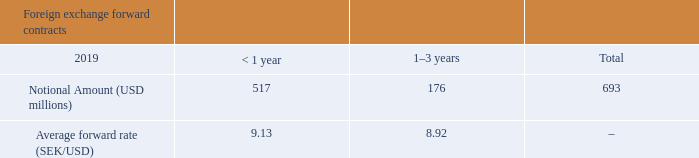The Company is holding the following currency derivatives designated as hedging instruments:
Hedge ratio is 1:1 and changes in forward rate have been designated as the hedged risk. The change in the fair value of the hedging instrument is compared with the change in fair value of the hedged item, and the lower amount
is taken to OCI. If the change in fair value of the hedging instrument is higher, then the excess change in fair value is considered ineffective hedging and recorded in net foreign exchange gains and losses. Upon recognition of the
hedged net sales, the cumulative amount in hedging reserve is released in the OCI as a reclassification adjustment and recognized in net sales.
See note E1, “Equity” for movement in the cash flow hedge reserve. No hedged net sales were recognized in 2019, hence no amount was released from hedging reserve in the OCI. No hedge ineffectiveness was recognized in
the income statement in 2019.
What is the hedge ratio? 1:1. Is hedge effectiveness recognized in 2019 income statement? No. What is the notional amount in USD for 2019 forward contracts that are less than 1 year?
Answer scale should be: million. 517. What is the difference in notional amount between those less than 1 year and 1-3 years?
Answer scale should be: million. 517-176
Answer: 341. What is the difference in average forward rate between those <1 and 1-3 years? 9.13-8.92
Answer: 0.21. What is the percentage constitution of the notional amount of foreign exchange forward contracts that are less than a year among the total notional amount?
Answer scale should be: percent. 517/693
Answer: 74.6. 